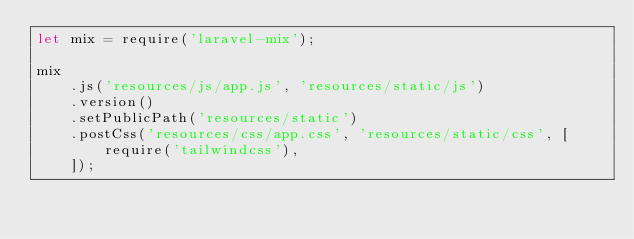Convert code to text. <code><loc_0><loc_0><loc_500><loc_500><_JavaScript_>let mix = require('laravel-mix');

mix
    .js('resources/js/app.js', 'resources/static/js')
    .version()
    .setPublicPath('resources/static')
    .postCss('resources/css/app.css', 'resources/static/css', [
        require('tailwindcss'),
    ]);</code> 